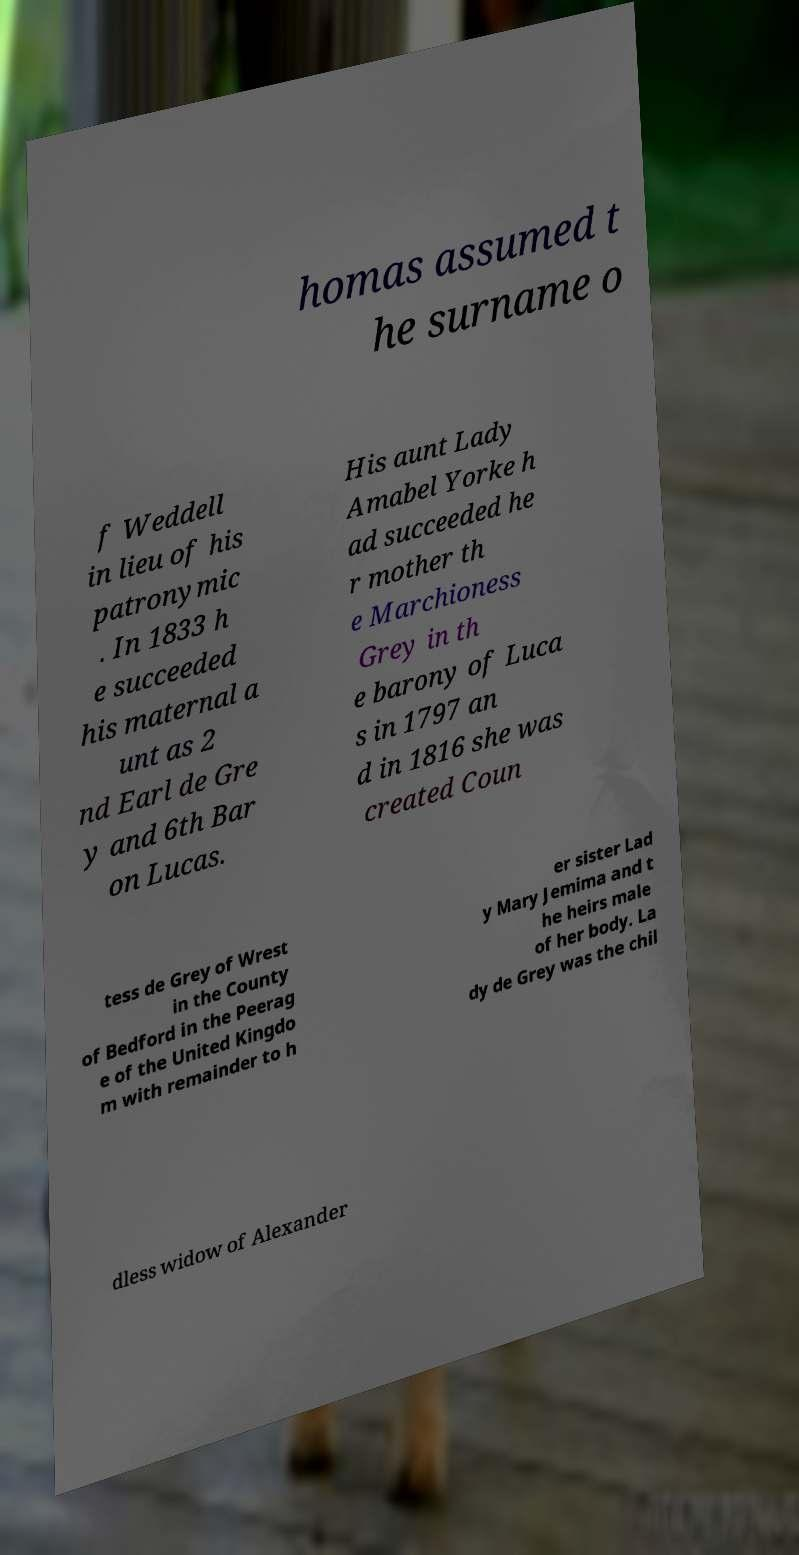What messages or text are displayed in this image? I need them in a readable, typed format. homas assumed t he surname o f Weddell in lieu of his patronymic . In 1833 h e succeeded his maternal a unt as 2 nd Earl de Gre y and 6th Bar on Lucas. His aunt Lady Amabel Yorke h ad succeeded he r mother th e Marchioness Grey in th e barony of Luca s in 1797 an d in 1816 she was created Coun tess de Grey of Wrest in the County of Bedford in the Peerag e of the United Kingdo m with remainder to h er sister Lad y Mary Jemima and t he heirs male of her body. La dy de Grey was the chil dless widow of Alexander 